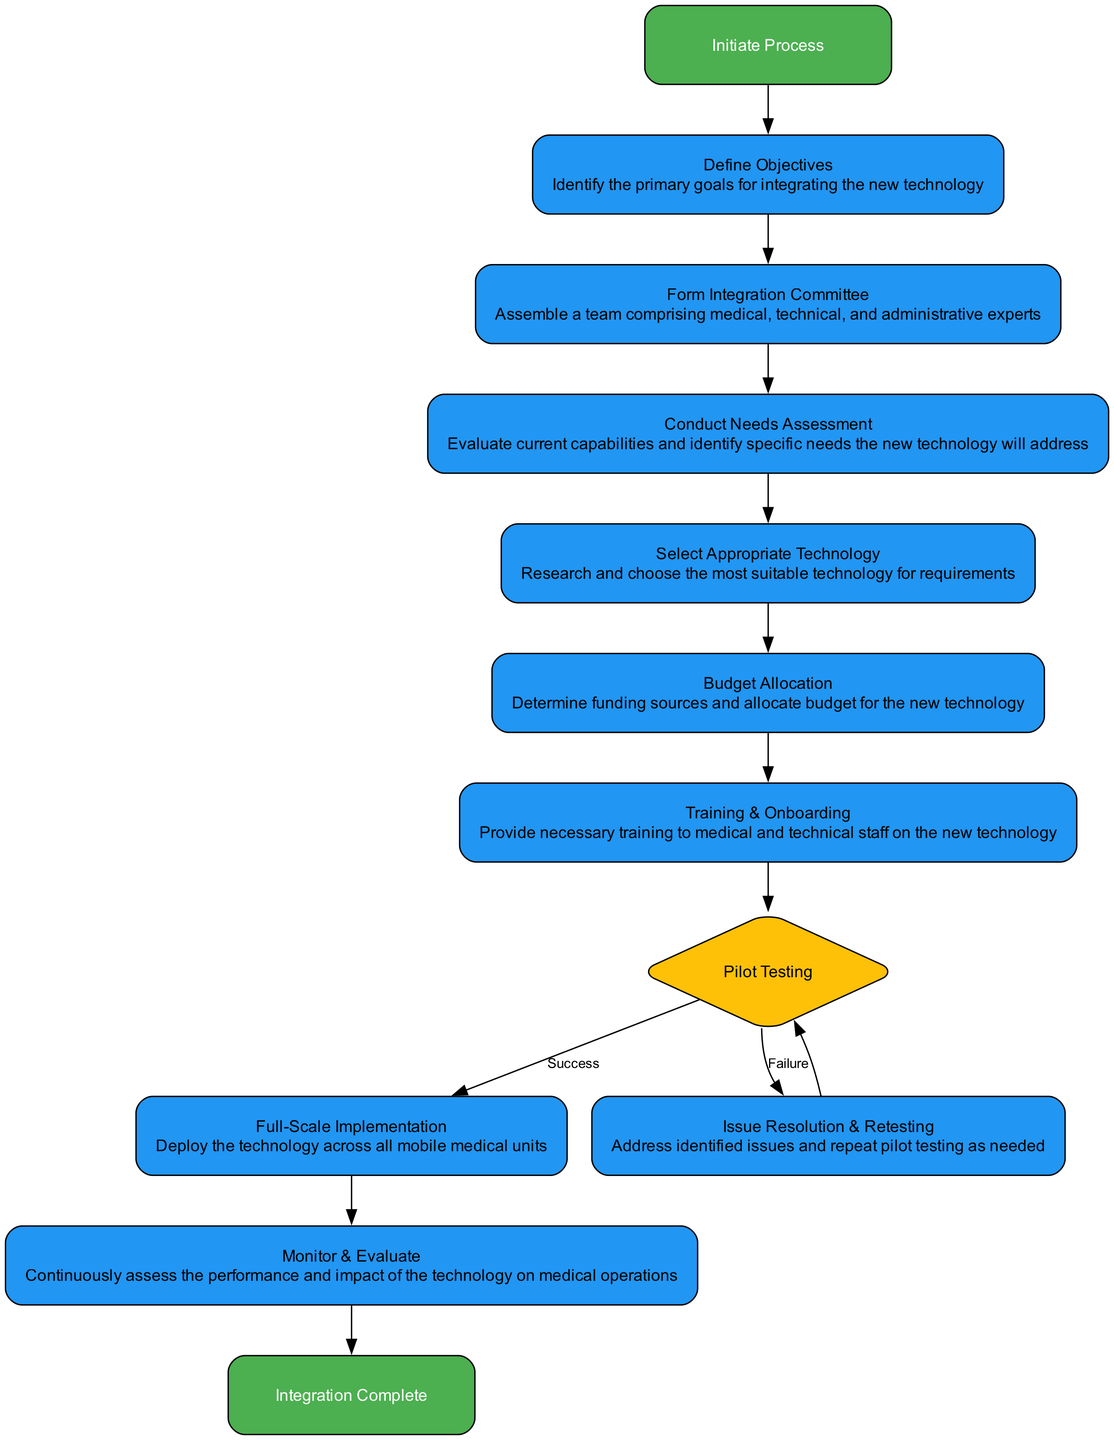What is the first step in the integration process? The first step indicated in the flowchart is labeled "Start", which leads to "Define Objectives" as the next action.
Answer: Define Objectives How many nodes are included in the diagram? By counting the distinct action nodes and decision points shown in the flowchart, there are ten unique nodes listed, not counting the start and end nodes.
Answer: Ten What is the output after the "Pilot Testing" step if issues are identified? If issues are identified during the "Pilot Testing," the flowchart indicates that the next action would be "Issue Resolution & Retesting." The diagram leads back to another "Pilot Testing" step following the resolution of issues.
Answer: Issue Resolution & Retesting What step follows "Training & Onboarding"? Following the "Training & Onboarding" step in the flowchart, the next action is "Pilot Testing." This indicates that training precedes the testing of the new technology.
Answer: Pilot Testing Which node has both a success and failure outcome? The node "Pilot Testing" is where the outcomes are split into "Success" and "Failure," indicating a decision point that determines the next steps based on the efficacy of the technology.
Answer: Pilot Testing What is the final node in the integration process? The last node indicated in the flowchart is "End Process," which signifies the completion of the technology integration after all prior steps have been successfully followed.
Answer: End Process What action is taken if the selected technology fails pilot testing? The action taken if the selected technology fails during pilot testing leads to "Issue Resolution & Retesting," indicating a process to address identified problems before re-testing.
Answer: Issue Resolution & Retesting Which node requires the formation of a committee? The "Form Integration Committee" step is necessary after defining objectives, highlighting the importance of collaboration among various experts to aid in the integration process.
Answer: Form Integration Committee How does one initiate the technology integration process? The process is initiated by the "Start" node, which is the first step that leads to defining objectives, thereby setting the foundation for the integration efforts.
Answer: Start 